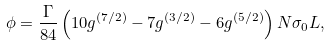Convert formula to latex. <formula><loc_0><loc_0><loc_500><loc_500>\phi = \frac { \Gamma } { 8 4 } \left ( 1 0 g ^ { ( 7 / 2 ) } - 7 g ^ { ( 3 / 2 ) } - 6 g ^ { ( 5 / 2 ) } \right ) N \sigma _ { 0 } L ,</formula> 